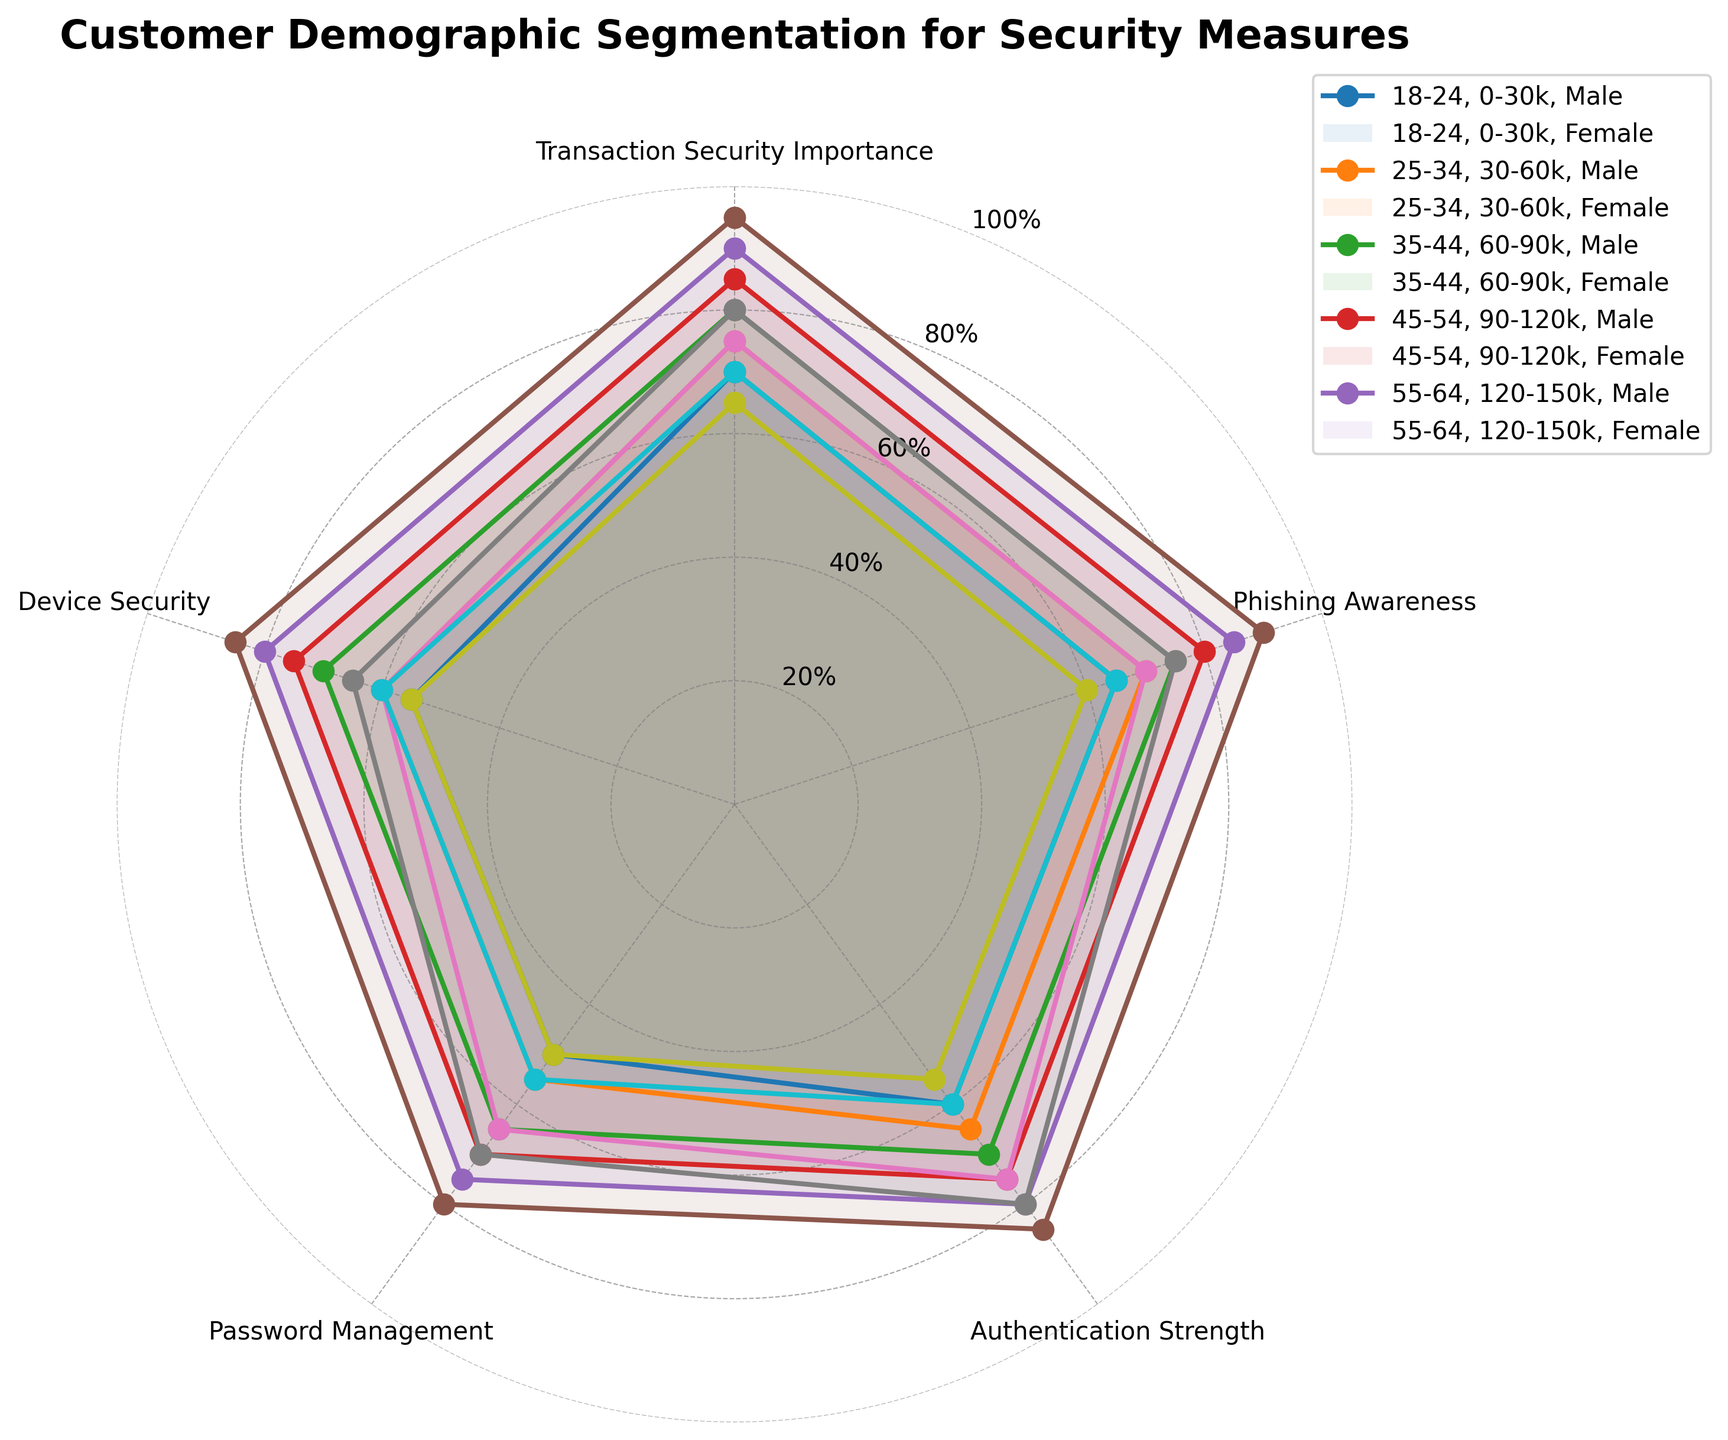What is the title of the radar chart? The radar chart's title is displayed at the top center. It reads 'Customer Demographic Segmentation for Security Measures'.
Answer: Customer Demographic Segmentation for Security Measures What are the categories represented in the petals of the radar chart? Each petal of the radar chart is labeled with a category. The categories are: 'Transaction Security Importance', 'Phishing Awareness', 'Authentication Strength', 'Password Management', and 'Device Security'.
Answer: Transaction Security Importance, Phishing Awareness, Authentication Strength, Password Management, Device Security Which demographic group has the highest score for 'Transaction Security Importance'? Review each demographic group's score along the 'Transaction Security Importance' category on the radar chart. The highest value is 95, belonging to the '35-44, 60-90k, Female' group.
Answer: 35-44, 60-90k, Female What is the average score for 'Device Security' across all demographic groups? Each demographic group's score for 'Device Security' is listed as follows: 55, 60, 70, 75, 80, 85, 60, 65, 55, 60. Summing these scores: 665, and dividing by the number of scores (10), the average score is 66.5.
Answer: 66.5 Compare the 'Phishing Awareness' scores between the age groups 25-34 with an income of 30-60k, and 45-54 with an income of 90-120k; which group is more aware? For 'Phishing Awareness', the 25-34, 30-60k, Male group has a score of 75, and Female has 80. For 45-54, 90-120k, Male has 70, and Female has 75. Both the 25-34 age groups score higher.
Answer: 25-34, 30-60k Which age and income group shows the greatest disparity between male and female scores in 'Authentication Strength’? Reviewing the 'Authentication Strength' scores: 18-24, 0-30k has a male score of 60 and a female score of 65, a difference of 5; 25-34, 30-60k: male 70, female 75, difference of 5; 35-44, 60-90k: male 80, female 85, difference of 5; 45-54, 90-120k: male 75, female 80, difference of 5; 55-64, 120-150k: male 55, female 60, difference of 5. The disparities are all equal, at 5 points.
Answer: All groups, 5 points disparity What is the range of 'Password Management' scores across all demographical groups? The 'Password Management' scores range can be found by identifying the minimum and maximum values. The scores are: 50, 55, 65, 70, 75, 80, 65, 70, 50, and 55. Therefore, the minimum score is 50 and the maximum score is 80.
Answer: 50 - 80 For the group '35-44, 60-90k, Female', list their scores across all security categories. The radar chart shows the scores for this demographic group across the categories: 'Transaction Security Importance' 95, 'Phishing Awareness' 90, 'Authentication Strength' 85, 'Password Management' 80, and 'Device Security' 85.
Answer: 95, 90, 85, 80, 85 